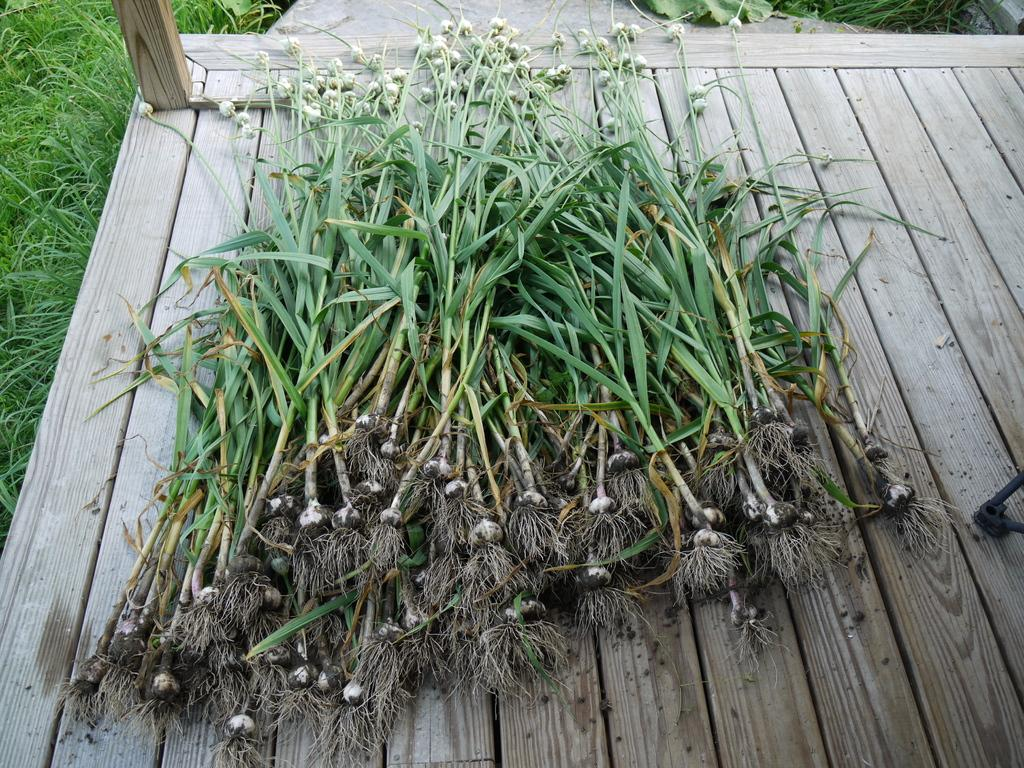What type of plants are on the wooden surface in the image? The plants appear to be spring onions. What is the wooden surface placed on in the image? The wooden surface is placed on the ground. What type of vegetation is visible on the ground around the wooden surface? There is grass on the ground around the wooden surface in the image. How many rabbits can be seen playing on the wooden surface in the image? There are no rabbits present in the image, and they are not playing on the wooden surface. 